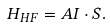<formula> <loc_0><loc_0><loc_500><loc_500>H _ { H F } = A { I } \cdot { S } .</formula> 